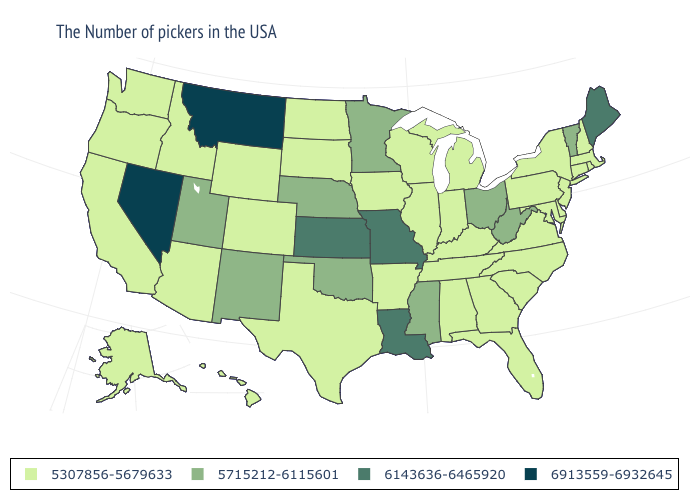Does South Carolina have the lowest value in the USA?
Answer briefly. Yes. What is the lowest value in the South?
Concise answer only. 5307856-5679633. What is the value of Arizona?
Concise answer only. 5307856-5679633. What is the lowest value in states that border Tennessee?
Quick response, please. 5307856-5679633. Name the states that have a value in the range 6913559-6932645?
Write a very short answer. Montana, Nevada. Does Wyoming have a lower value than New Jersey?
Concise answer only. No. What is the highest value in the USA?
Short answer required. 6913559-6932645. Name the states that have a value in the range 6143636-6465920?
Be succinct. Maine, Louisiana, Missouri, Kansas. Name the states that have a value in the range 5715212-6115601?
Be succinct. Vermont, West Virginia, Ohio, Mississippi, Minnesota, Nebraska, Oklahoma, New Mexico, Utah. What is the lowest value in states that border Indiana?
Give a very brief answer. 5307856-5679633. What is the value of Mississippi?
Concise answer only. 5715212-6115601. Which states have the lowest value in the USA?
Keep it brief. Massachusetts, Rhode Island, New Hampshire, Connecticut, New York, New Jersey, Delaware, Maryland, Pennsylvania, Virginia, North Carolina, South Carolina, Florida, Georgia, Michigan, Kentucky, Indiana, Alabama, Tennessee, Wisconsin, Illinois, Arkansas, Iowa, Texas, South Dakota, North Dakota, Wyoming, Colorado, Arizona, Idaho, California, Washington, Oregon, Alaska, Hawaii. Which states have the lowest value in the USA?
Quick response, please. Massachusetts, Rhode Island, New Hampshire, Connecticut, New York, New Jersey, Delaware, Maryland, Pennsylvania, Virginia, North Carolina, South Carolina, Florida, Georgia, Michigan, Kentucky, Indiana, Alabama, Tennessee, Wisconsin, Illinois, Arkansas, Iowa, Texas, South Dakota, North Dakota, Wyoming, Colorado, Arizona, Idaho, California, Washington, Oregon, Alaska, Hawaii. Which states have the highest value in the USA?
Quick response, please. Montana, Nevada. 